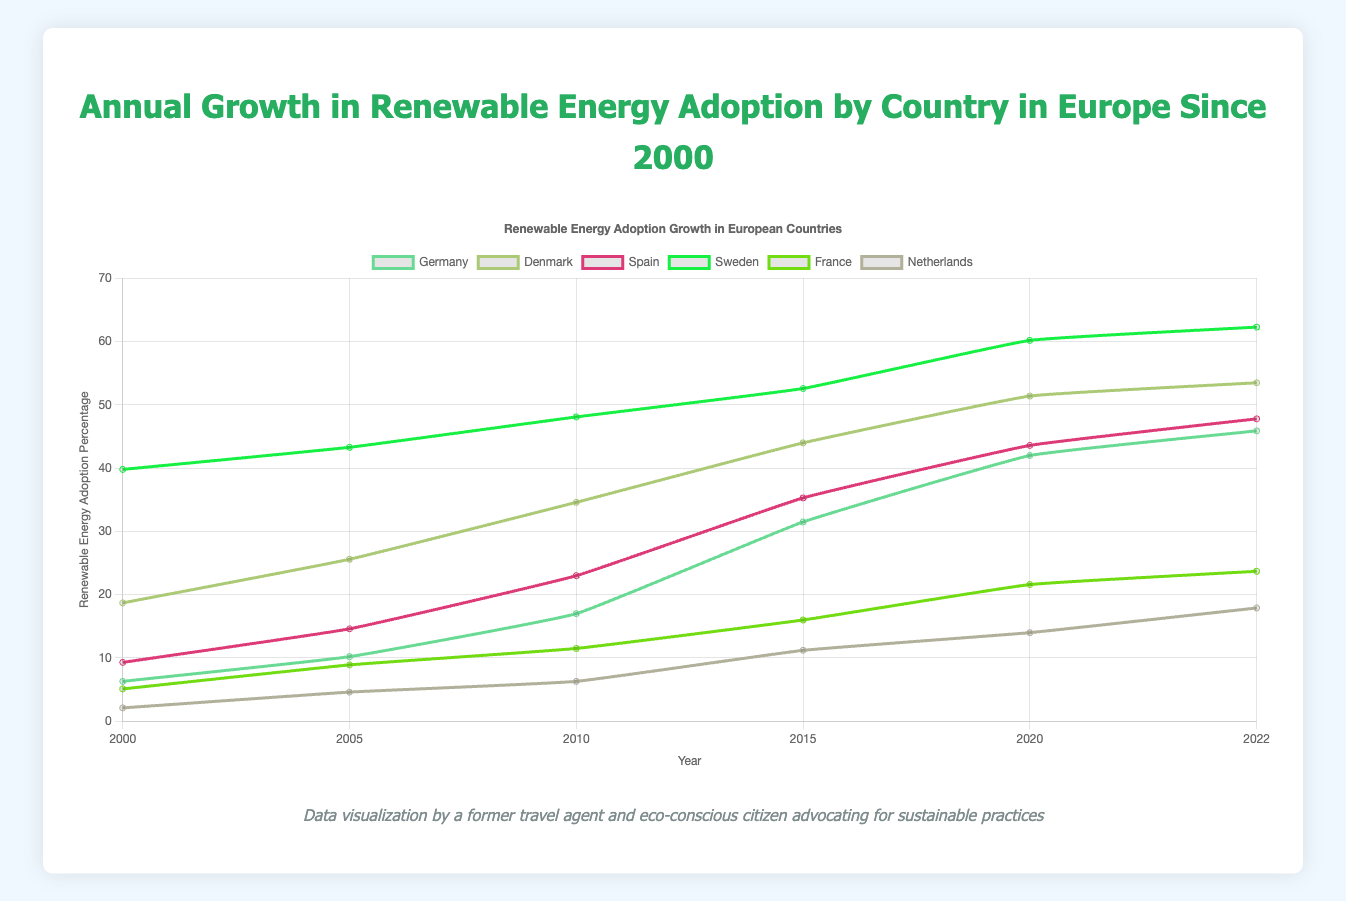Which country had the highest renewable energy adoption percentage in 2022? By scanning the chart for the year 2022, identify the country with the highest percentage value which is marked on the y-axis.
Answer: Sweden What was the difference in renewable energy adoption percentage between Germany and Spain in 2020? Locate the renewable energy adoption percentages for Germany and Spain in 2020 on the chart. Subtract Spain's percentage from Germany's percentage: 42.0% - 43.6%.
Answer: -1.6 How much did Denmark's renewable energy adoption increase from 2000 to 2022? Find the percentages for Denmark in 2000 and 2022 from the chart. Subtract the 2000 value from the 2022 value: 53.5% - 18.7%.
Answer: 34.8 Which year did France reach a 20% adoption of renewable energy? Identify the year when France's renewable energy percentage reaches or exceeds 20% by checking the line graph for France.
Answer: 2020 How many years did it take for Sweden to increase its renewable energy adoption percentage by 10% from 2005? Find the points on Sweden's line where the percentage increased by 10% from the 2005 value (43.3% + 10%). Identify the years and calculate the difference in years: 48.1% in 2010, 52.6% in 2015, so approx 5 years in 2010.
Answer: 5 Is there any country that experienced a decline in renewable energy adoption percentage between two consecutive years? Check each country's line graph for any downward slope between consecutive data points.
Answer: No Which country showed the most consistent growth in renewable energy adoption percentages? Compare the slopes of all the countries' lines. Identify the country whose line shows a steady upward trend without significant fluctuations.
Answer: Sweden Compare the renewable energy adoption percentages between Sweden and the Netherlands in 2022. Read the percentage values for Sweden and the Netherlands in 2022 from the chart and compare them.
Answer: 62.3 (Sweden) > 17.9 (Netherlands) What was the average renewable energy adoption percentage for Denmark across all the years shown? Add Denmark’s percentages for all the years, then divide by the number of years: (18.7 + 25.6 + 34.6 + 44.0 + 51.4 + 53.5) / 6.
Answer: 37.97 